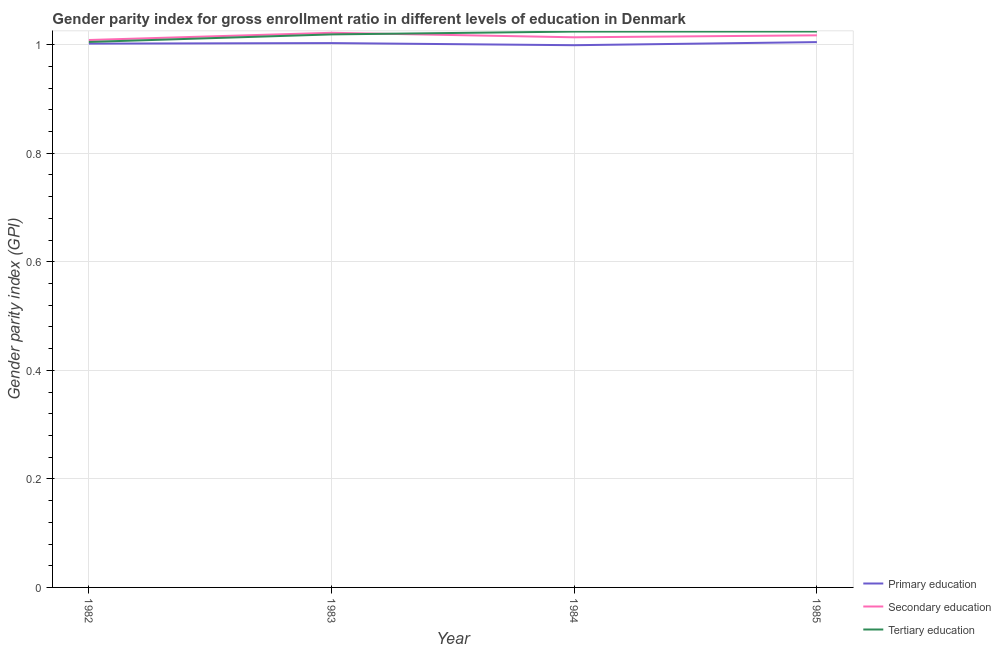Does the line corresponding to gender parity index in primary education intersect with the line corresponding to gender parity index in secondary education?
Your response must be concise. No. Is the number of lines equal to the number of legend labels?
Keep it short and to the point. Yes. What is the gender parity index in primary education in 1984?
Your answer should be very brief. 1. Across all years, what is the maximum gender parity index in secondary education?
Your answer should be very brief. 1.02. Across all years, what is the minimum gender parity index in primary education?
Your answer should be compact. 1. What is the total gender parity index in secondary education in the graph?
Your response must be concise. 4.06. What is the difference between the gender parity index in primary education in 1983 and that in 1985?
Ensure brevity in your answer.  -0. What is the difference between the gender parity index in primary education in 1984 and the gender parity index in secondary education in 1985?
Your answer should be compact. -0.02. What is the average gender parity index in tertiary education per year?
Give a very brief answer. 1.02. In the year 1982, what is the difference between the gender parity index in tertiary education and gender parity index in secondary education?
Your answer should be compact. -0. In how many years, is the gender parity index in primary education greater than 0.48000000000000004?
Provide a short and direct response. 4. What is the ratio of the gender parity index in tertiary education in 1982 to that in 1985?
Your answer should be compact. 0.98. Is the difference between the gender parity index in secondary education in 1983 and 1984 greater than the difference between the gender parity index in primary education in 1983 and 1984?
Offer a very short reply. Yes. What is the difference between the highest and the second highest gender parity index in primary education?
Ensure brevity in your answer.  0. What is the difference between the highest and the lowest gender parity index in secondary education?
Your answer should be very brief. 0.01. Does the gender parity index in primary education monotonically increase over the years?
Give a very brief answer. No. How many lines are there?
Provide a succinct answer. 3. How many years are there in the graph?
Keep it short and to the point. 4. Are the values on the major ticks of Y-axis written in scientific E-notation?
Your answer should be compact. No. Does the graph contain any zero values?
Provide a succinct answer. No. Does the graph contain grids?
Keep it short and to the point. Yes. How many legend labels are there?
Your response must be concise. 3. How are the legend labels stacked?
Offer a terse response. Vertical. What is the title of the graph?
Offer a terse response. Gender parity index for gross enrollment ratio in different levels of education in Denmark. Does "Injury" appear as one of the legend labels in the graph?
Provide a succinct answer. No. What is the label or title of the Y-axis?
Provide a succinct answer. Gender parity index (GPI). What is the Gender parity index (GPI) in Primary education in 1982?
Keep it short and to the point. 1. What is the Gender parity index (GPI) of Secondary education in 1982?
Give a very brief answer. 1.01. What is the Gender parity index (GPI) of Tertiary education in 1982?
Provide a succinct answer. 1. What is the Gender parity index (GPI) in Primary education in 1983?
Provide a succinct answer. 1. What is the Gender parity index (GPI) of Secondary education in 1983?
Provide a succinct answer. 1.02. What is the Gender parity index (GPI) of Tertiary education in 1983?
Give a very brief answer. 1.02. What is the Gender parity index (GPI) of Primary education in 1984?
Your response must be concise. 1. What is the Gender parity index (GPI) in Secondary education in 1984?
Offer a terse response. 1.01. What is the Gender parity index (GPI) of Primary education in 1985?
Your answer should be compact. 1. What is the Gender parity index (GPI) in Secondary education in 1985?
Your answer should be very brief. 1.02. What is the Gender parity index (GPI) of Tertiary education in 1985?
Offer a terse response. 1.02. Across all years, what is the maximum Gender parity index (GPI) in Primary education?
Provide a succinct answer. 1. Across all years, what is the maximum Gender parity index (GPI) of Secondary education?
Keep it short and to the point. 1.02. Across all years, what is the maximum Gender parity index (GPI) in Tertiary education?
Provide a succinct answer. 1.02. Across all years, what is the minimum Gender parity index (GPI) of Primary education?
Make the answer very short. 1. Across all years, what is the minimum Gender parity index (GPI) of Secondary education?
Make the answer very short. 1.01. Across all years, what is the minimum Gender parity index (GPI) of Tertiary education?
Your response must be concise. 1. What is the total Gender parity index (GPI) in Primary education in the graph?
Give a very brief answer. 4.01. What is the total Gender parity index (GPI) in Secondary education in the graph?
Provide a short and direct response. 4.06. What is the total Gender parity index (GPI) in Tertiary education in the graph?
Make the answer very short. 4.07. What is the difference between the Gender parity index (GPI) in Primary education in 1982 and that in 1983?
Offer a terse response. -0. What is the difference between the Gender parity index (GPI) of Secondary education in 1982 and that in 1983?
Your answer should be compact. -0.01. What is the difference between the Gender parity index (GPI) of Tertiary education in 1982 and that in 1983?
Provide a short and direct response. -0.01. What is the difference between the Gender parity index (GPI) in Primary education in 1982 and that in 1984?
Give a very brief answer. 0. What is the difference between the Gender parity index (GPI) of Secondary education in 1982 and that in 1984?
Offer a very short reply. -0.01. What is the difference between the Gender parity index (GPI) in Tertiary education in 1982 and that in 1984?
Ensure brevity in your answer.  -0.02. What is the difference between the Gender parity index (GPI) in Primary education in 1982 and that in 1985?
Your answer should be very brief. -0. What is the difference between the Gender parity index (GPI) of Secondary education in 1982 and that in 1985?
Offer a very short reply. -0.01. What is the difference between the Gender parity index (GPI) of Tertiary education in 1982 and that in 1985?
Offer a terse response. -0.02. What is the difference between the Gender parity index (GPI) of Primary education in 1983 and that in 1984?
Give a very brief answer. 0. What is the difference between the Gender parity index (GPI) in Secondary education in 1983 and that in 1984?
Your answer should be very brief. 0.01. What is the difference between the Gender parity index (GPI) of Tertiary education in 1983 and that in 1984?
Make the answer very short. -0.01. What is the difference between the Gender parity index (GPI) in Primary education in 1983 and that in 1985?
Offer a terse response. -0. What is the difference between the Gender parity index (GPI) of Secondary education in 1983 and that in 1985?
Your response must be concise. 0. What is the difference between the Gender parity index (GPI) in Tertiary education in 1983 and that in 1985?
Your answer should be compact. -0.01. What is the difference between the Gender parity index (GPI) in Primary education in 1984 and that in 1985?
Offer a very short reply. -0.01. What is the difference between the Gender parity index (GPI) in Secondary education in 1984 and that in 1985?
Offer a very short reply. -0. What is the difference between the Gender parity index (GPI) in Tertiary education in 1984 and that in 1985?
Your answer should be compact. -0. What is the difference between the Gender parity index (GPI) in Primary education in 1982 and the Gender parity index (GPI) in Secondary education in 1983?
Offer a terse response. -0.02. What is the difference between the Gender parity index (GPI) in Primary education in 1982 and the Gender parity index (GPI) in Tertiary education in 1983?
Make the answer very short. -0.02. What is the difference between the Gender parity index (GPI) in Secondary education in 1982 and the Gender parity index (GPI) in Tertiary education in 1983?
Offer a terse response. -0.01. What is the difference between the Gender parity index (GPI) in Primary education in 1982 and the Gender parity index (GPI) in Secondary education in 1984?
Offer a very short reply. -0.01. What is the difference between the Gender parity index (GPI) in Primary education in 1982 and the Gender parity index (GPI) in Tertiary education in 1984?
Make the answer very short. -0.02. What is the difference between the Gender parity index (GPI) in Secondary education in 1982 and the Gender parity index (GPI) in Tertiary education in 1984?
Provide a short and direct response. -0.02. What is the difference between the Gender parity index (GPI) of Primary education in 1982 and the Gender parity index (GPI) of Secondary education in 1985?
Give a very brief answer. -0.02. What is the difference between the Gender parity index (GPI) in Primary education in 1982 and the Gender parity index (GPI) in Tertiary education in 1985?
Give a very brief answer. -0.02. What is the difference between the Gender parity index (GPI) in Secondary education in 1982 and the Gender parity index (GPI) in Tertiary education in 1985?
Offer a terse response. -0.02. What is the difference between the Gender parity index (GPI) in Primary education in 1983 and the Gender parity index (GPI) in Secondary education in 1984?
Give a very brief answer. -0.01. What is the difference between the Gender parity index (GPI) in Primary education in 1983 and the Gender parity index (GPI) in Tertiary education in 1984?
Make the answer very short. -0.02. What is the difference between the Gender parity index (GPI) of Secondary education in 1983 and the Gender parity index (GPI) of Tertiary education in 1984?
Make the answer very short. -0. What is the difference between the Gender parity index (GPI) in Primary education in 1983 and the Gender parity index (GPI) in Secondary education in 1985?
Offer a very short reply. -0.01. What is the difference between the Gender parity index (GPI) in Primary education in 1983 and the Gender parity index (GPI) in Tertiary education in 1985?
Provide a short and direct response. -0.02. What is the difference between the Gender parity index (GPI) of Secondary education in 1983 and the Gender parity index (GPI) of Tertiary education in 1985?
Your answer should be very brief. -0. What is the difference between the Gender parity index (GPI) in Primary education in 1984 and the Gender parity index (GPI) in Secondary education in 1985?
Provide a succinct answer. -0.02. What is the difference between the Gender parity index (GPI) in Primary education in 1984 and the Gender parity index (GPI) in Tertiary education in 1985?
Provide a succinct answer. -0.03. What is the difference between the Gender parity index (GPI) of Secondary education in 1984 and the Gender parity index (GPI) of Tertiary education in 1985?
Provide a short and direct response. -0.01. What is the average Gender parity index (GPI) in Primary education per year?
Make the answer very short. 1. What is the average Gender parity index (GPI) of Secondary education per year?
Keep it short and to the point. 1.02. What is the average Gender parity index (GPI) of Tertiary education per year?
Ensure brevity in your answer.  1.02. In the year 1982, what is the difference between the Gender parity index (GPI) of Primary education and Gender parity index (GPI) of Secondary education?
Your answer should be very brief. -0.01. In the year 1982, what is the difference between the Gender parity index (GPI) of Primary education and Gender parity index (GPI) of Tertiary education?
Offer a terse response. -0. In the year 1982, what is the difference between the Gender parity index (GPI) in Secondary education and Gender parity index (GPI) in Tertiary education?
Offer a terse response. 0. In the year 1983, what is the difference between the Gender parity index (GPI) of Primary education and Gender parity index (GPI) of Secondary education?
Make the answer very short. -0.02. In the year 1983, what is the difference between the Gender parity index (GPI) in Primary education and Gender parity index (GPI) in Tertiary education?
Give a very brief answer. -0.02. In the year 1983, what is the difference between the Gender parity index (GPI) of Secondary education and Gender parity index (GPI) of Tertiary education?
Make the answer very short. 0. In the year 1984, what is the difference between the Gender parity index (GPI) of Primary education and Gender parity index (GPI) of Secondary education?
Your answer should be very brief. -0.01. In the year 1984, what is the difference between the Gender parity index (GPI) in Primary education and Gender parity index (GPI) in Tertiary education?
Give a very brief answer. -0.03. In the year 1984, what is the difference between the Gender parity index (GPI) in Secondary education and Gender parity index (GPI) in Tertiary education?
Your answer should be compact. -0.01. In the year 1985, what is the difference between the Gender parity index (GPI) in Primary education and Gender parity index (GPI) in Secondary education?
Your answer should be very brief. -0.01. In the year 1985, what is the difference between the Gender parity index (GPI) in Primary education and Gender parity index (GPI) in Tertiary education?
Your response must be concise. -0.02. In the year 1985, what is the difference between the Gender parity index (GPI) of Secondary education and Gender parity index (GPI) of Tertiary education?
Keep it short and to the point. -0.01. What is the ratio of the Gender parity index (GPI) in Primary education in 1982 to that in 1983?
Provide a succinct answer. 1. What is the ratio of the Gender parity index (GPI) in Secondary education in 1982 to that in 1983?
Keep it short and to the point. 0.99. What is the ratio of the Gender parity index (GPI) in Tertiary education in 1982 to that in 1983?
Ensure brevity in your answer.  0.99. What is the ratio of the Gender parity index (GPI) in Tertiary education in 1982 to that in 1984?
Offer a terse response. 0.98. What is the ratio of the Gender parity index (GPI) of Primary education in 1982 to that in 1985?
Your answer should be compact. 1. What is the ratio of the Gender parity index (GPI) of Secondary education in 1982 to that in 1985?
Provide a short and direct response. 0.99. What is the ratio of the Gender parity index (GPI) of Tertiary education in 1982 to that in 1985?
Your response must be concise. 0.98. What is the ratio of the Gender parity index (GPI) in Secondary education in 1983 to that in 1984?
Offer a very short reply. 1.01. What is the ratio of the Gender parity index (GPI) of Tertiary education in 1983 to that in 1984?
Keep it short and to the point. 0.99. What is the ratio of the Gender parity index (GPI) in Secondary education in 1983 to that in 1985?
Your response must be concise. 1. What is the difference between the highest and the second highest Gender parity index (GPI) of Primary education?
Offer a terse response. 0. What is the difference between the highest and the second highest Gender parity index (GPI) in Secondary education?
Offer a terse response. 0. What is the difference between the highest and the lowest Gender parity index (GPI) of Primary education?
Offer a very short reply. 0.01. What is the difference between the highest and the lowest Gender parity index (GPI) in Secondary education?
Your response must be concise. 0.01. What is the difference between the highest and the lowest Gender parity index (GPI) in Tertiary education?
Provide a succinct answer. 0.02. 